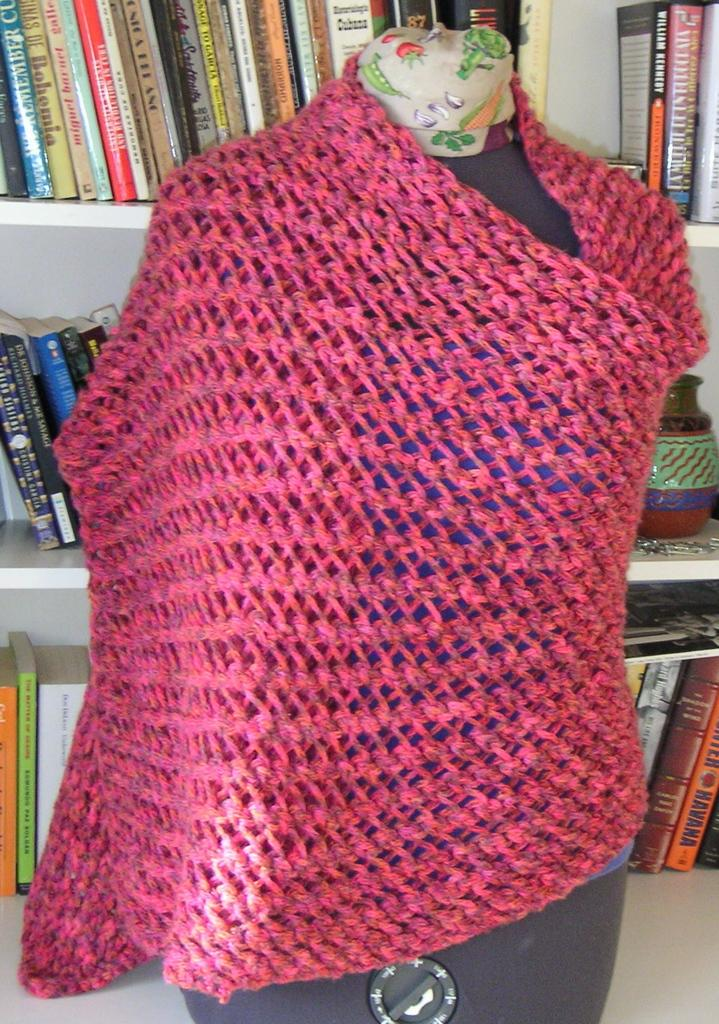What is wrapped in the woolen cloth in the image? The fact does not specify what the woolen cloth is wrapped around, so we cannot determine that from the information provided. Can you describe the white cloth in the image? There is a white cloth with a design in the image. What can be seen in the background of the image? There are books and a vase on a shelf in the background of the image. What type of property does the laborer own in the image? There is no laborer or property present in the image. How does the mind of the person in the image perceive the design on the white cloth? The image does not provide any information about the person's mind or perception, so we cannot determine that from the information provided. 